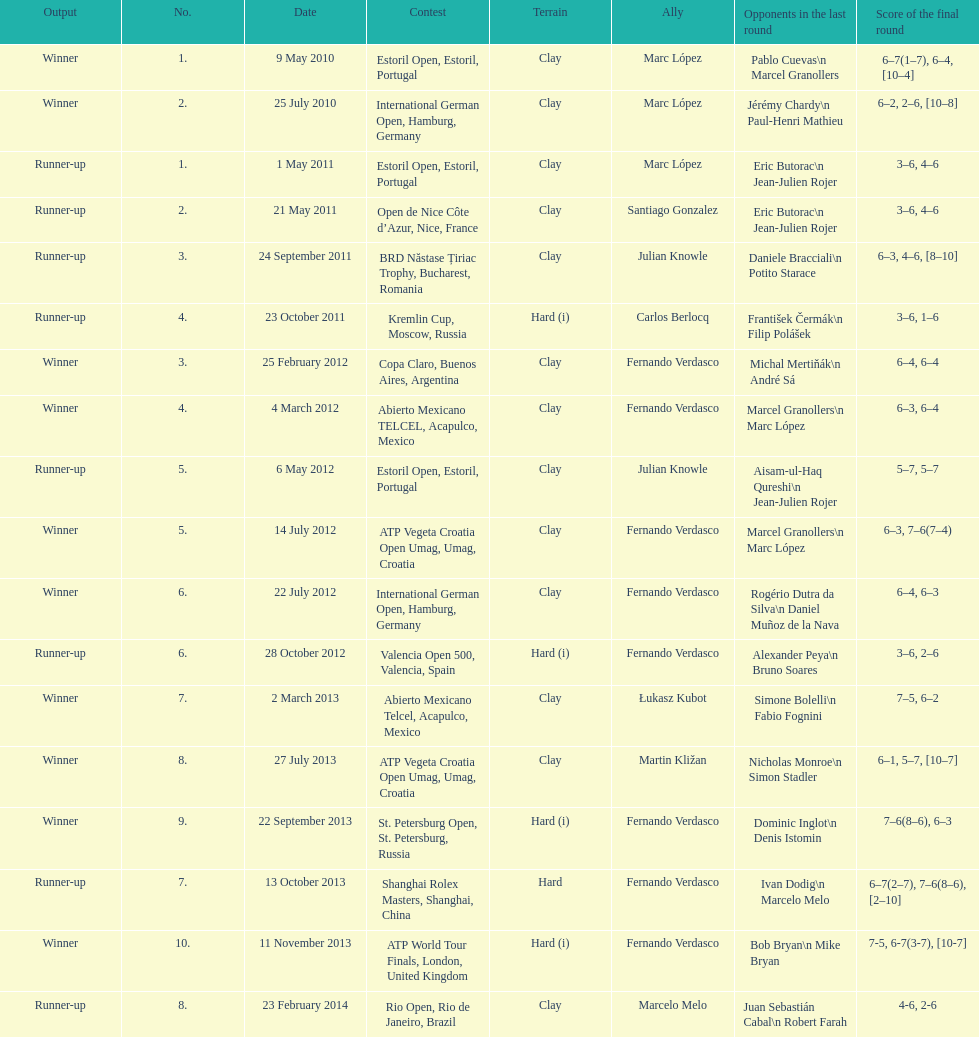Which tournament has the largest number? ATP World Tour Finals. 